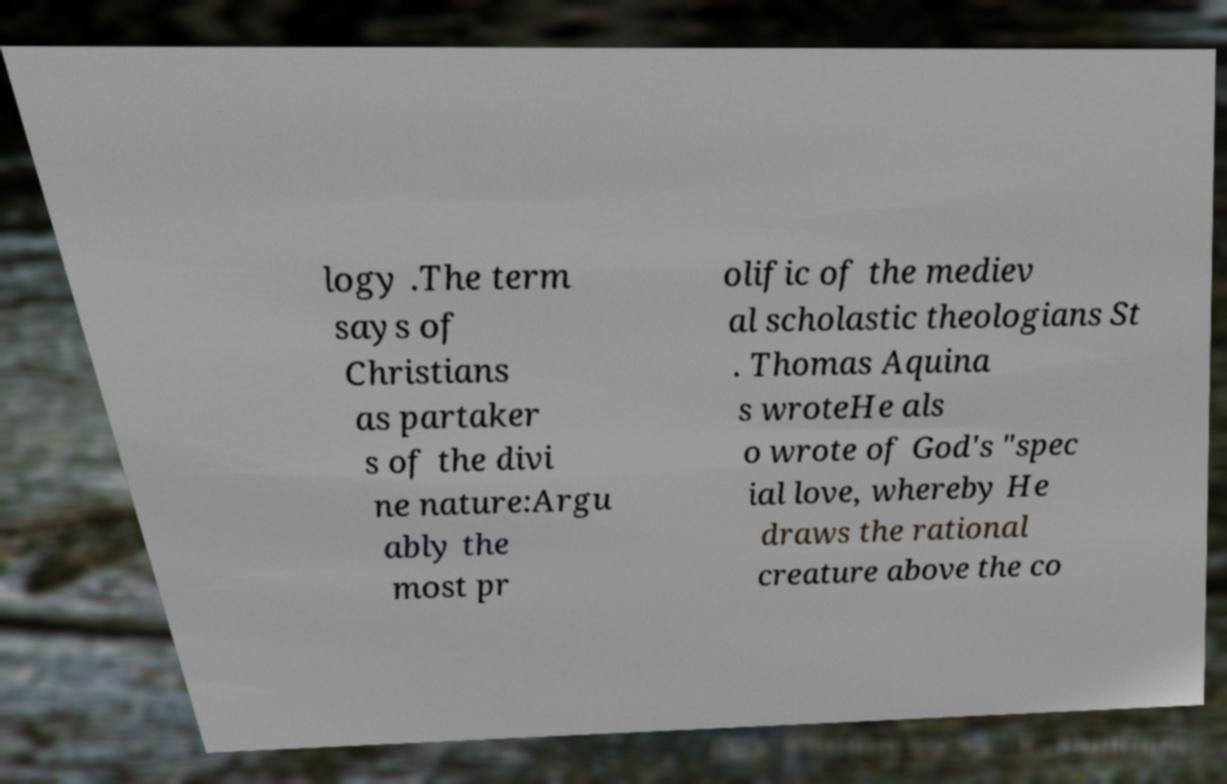I need the written content from this picture converted into text. Can you do that? logy .The term says of Christians as partaker s of the divi ne nature:Argu ably the most pr olific of the mediev al scholastic theologians St . Thomas Aquina s wroteHe als o wrote of God's "spec ial love, whereby He draws the rational creature above the co 